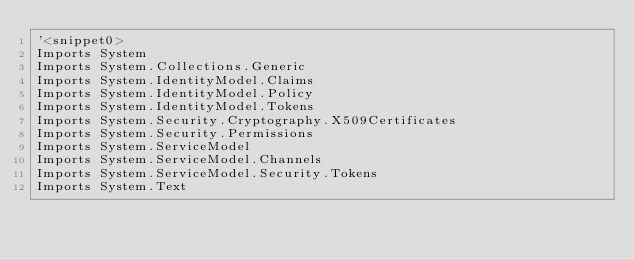Convert code to text. <code><loc_0><loc_0><loc_500><loc_500><_VisualBasic_>'<snippet0>
Imports System
Imports System.Collections.Generic
Imports System.IdentityModel.Claims
Imports System.IdentityModel.Policy
Imports System.IdentityModel.Tokens
Imports System.Security.Cryptography.X509Certificates
Imports System.Security.Permissions
Imports System.ServiceModel
Imports System.ServiceModel.Channels
Imports System.ServiceModel.Security.Tokens
Imports System.Text</code> 